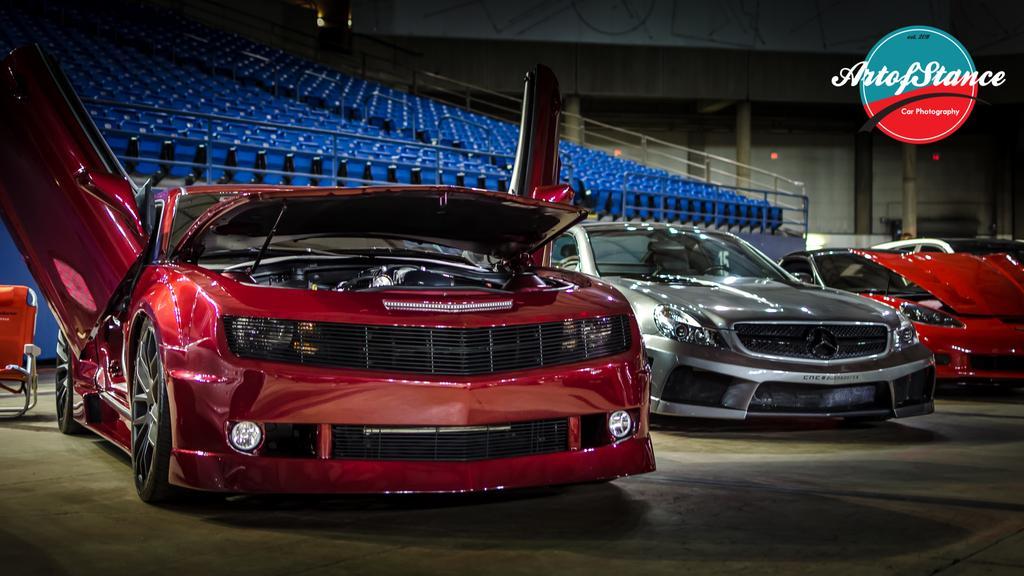In one or two sentences, can you explain what this image depicts? In this picture I can see there are few cars parked here and there is a red color car at the left and it has a door, headlight, wheel and there are few more cars parked on to right. There is a silver car at the right side and there is another car. There are many empty chairs in the backdrop and there are few pillars onto right side. 